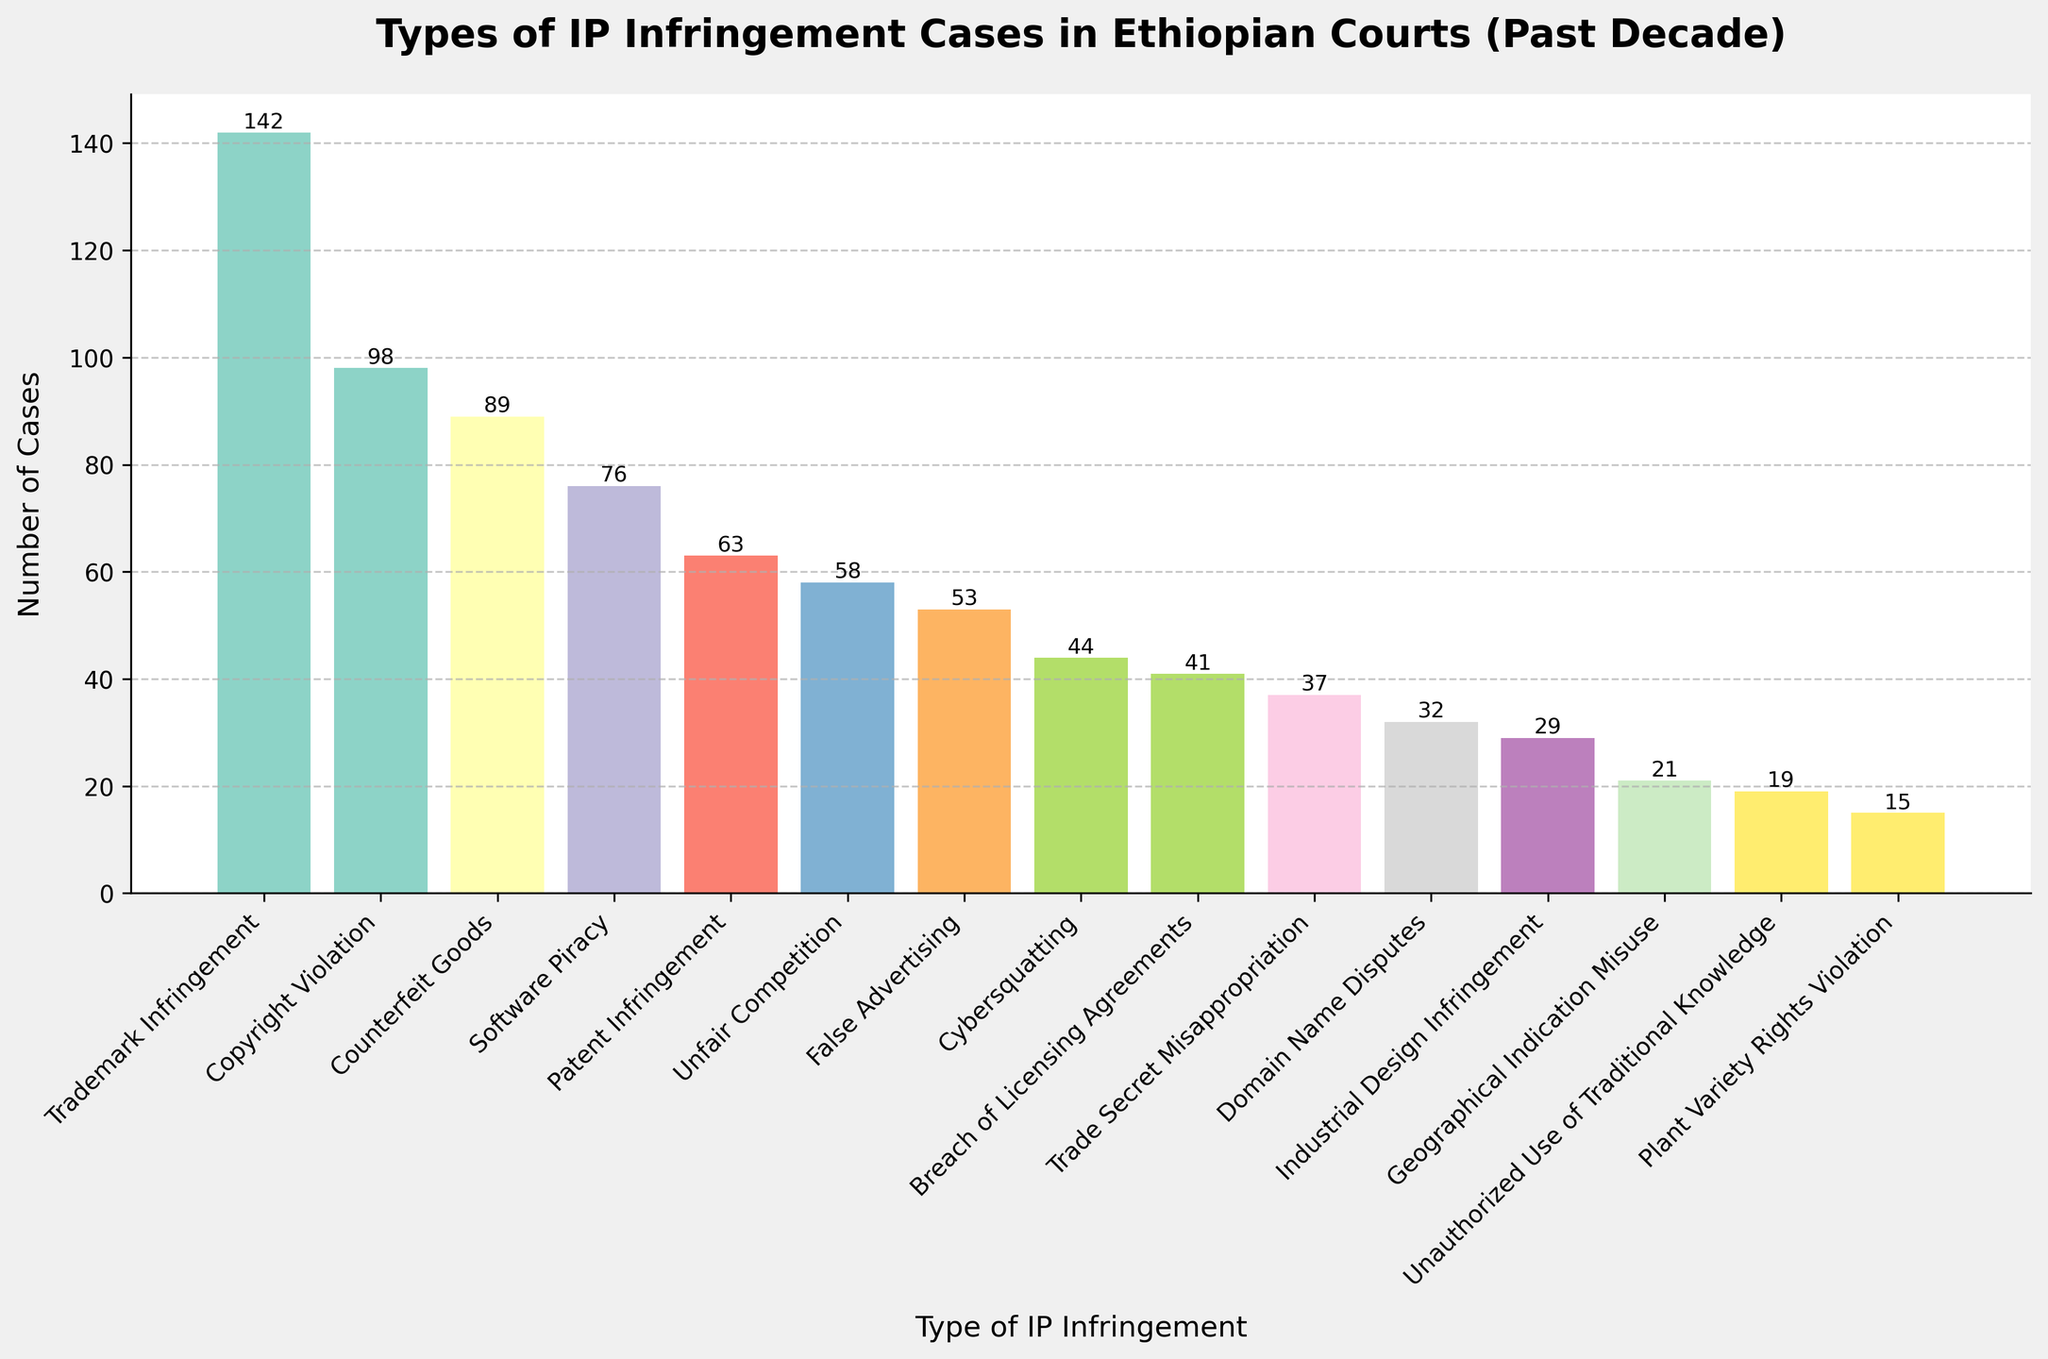Which type of IP infringement had the highest number of cases? The bar labeled "Trademark Infringement" is the highest, indicating it has the most number of cases.
Answer: Trademark Infringement What is the sum of cases for Patent Infringement and Trade Secret Misappropriation? Patent Infringement has 63 cases and Trade Secret Misappropriation has 37 cases. Adding these together gives 63 + 37 = 100.
Answer: 100 Which type has fewer cases: Geographical Indication Misuse or Plant Variety Rights Violation? The bar for Plant Variety Rights Violation is shorter than Geographical Indication Misuse; Plant Variety Rights Violation has 15 cases and Geographical Indication Misuse has 21 cases.
Answer: Plant Variety Rights Violation How many more cases does Copyright Violation have compared to Software Piracy? Copyright Violation has 98 cases and Software Piracy has 76 cases. The difference is 98 - 76 = 22.
Answer: 22 Identify the color of the bar representing Counterfeit Goods. The color of the bar for Counterfeit Goods can be identified visually from the chart.
Answer: The color is visually identifiable from the chart What is the total number of cases for the three least frequent types of IP infringement? The least frequent types are Plant Variety Rights Violation (15), Unauthorized Use of Traditional Knowledge (19), and Geographical Indication Misuse (21). Adding these gives 15 + 19 + 21 = 55.
Answer: 55 Which type of IP infringement has a similar number of cases to Breach of Licensing Agreements? By comparing the bar heights, Domain Name Disputes has a similar number of cases to Breach of Licensing Agreements; both have around 41 and 32 cases respectively.
Answer: Domain Name Disputes Is the number of False Advertising cases greater than Unfair Competition? The bar for False Advertising shows 53 cases, while Unfair Competition has 58 cases, so False Advertising is less than Unfair Competition.
Answer: No What percentage of the total IP infringement cases does Trademark Infringement represent? First, sum all the cases: 142 + 98 + 63 + 37 + 29 + 21 + 15 + 58 + 44 + 89 + 32 + 76 + 19 + 41 + 53 = 817. Then, calculate the percentage for Trademark Infringement: (142/817) * 100 = approximately 17.38%.
Answer: 17.38% Order the types of IP infringement with more than 50 cases from most to least. From the figure, the types with more than 50 cases are: Trademark Infringement (142), Copyright Violation (98), Counterfeit Goods (89), Software Piracy (76), Unfair Competition (58), and False Advertising (53). Listing them in descending order based on cases: (1) Trademark Infringement, (2) Copyright Violation, (3) Counterfeit Goods, (4) Software Piracy, (5) Unfair Competition, (6) False Advertising.
Answer: Trademark Infringement, Copyright Violation, Counterfeit Goods, Software Piracy, Unfair Competition, False Advertising 